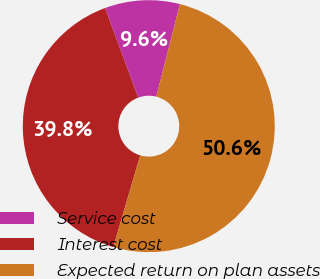Convert chart. <chart><loc_0><loc_0><loc_500><loc_500><pie_chart><fcel>Service cost<fcel>Interest cost<fcel>Expected return on plan assets<nl><fcel>9.62%<fcel>39.81%<fcel>50.56%<nl></chart> 